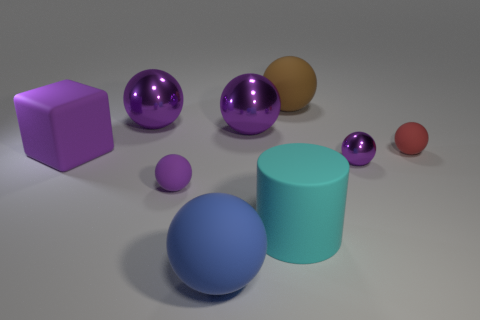If this were a photograph of real objects, what kind of lighting setup might be used to achieve this appearance? If this were a photograph, it would likely require a controlled lighting setup to achieve the soft shadows and even illumination seen here. A key light, perhaps a large, diffused source placed above and slightly in front of the objects, would provide the main illumination. Fill lights or reflectors could be used to soften shadows and reduce contrast, lending the scene the soft, evenly lit quality we see in the image. 